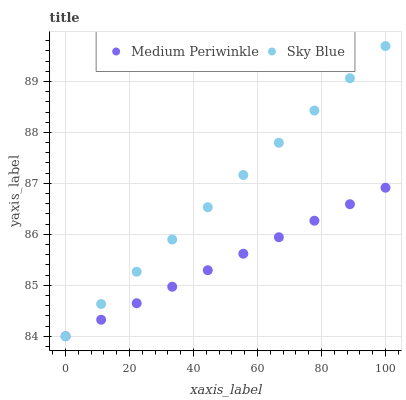Does Medium Periwinkle have the minimum area under the curve?
Answer yes or no. Yes. Does Sky Blue have the maximum area under the curve?
Answer yes or no. Yes. Does Medium Periwinkle have the maximum area under the curve?
Answer yes or no. No. Is Medium Periwinkle the smoothest?
Answer yes or no. Yes. Is Sky Blue the roughest?
Answer yes or no. Yes. Is Medium Periwinkle the roughest?
Answer yes or no. No. Does Sky Blue have the lowest value?
Answer yes or no. Yes. Does Sky Blue have the highest value?
Answer yes or no. Yes. Does Medium Periwinkle have the highest value?
Answer yes or no. No. Does Medium Periwinkle intersect Sky Blue?
Answer yes or no. Yes. Is Medium Periwinkle less than Sky Blue?
Answer yes or no. No. Is Medium Periwinkle greater than Sky Blue?
Answer yes or no. No. 